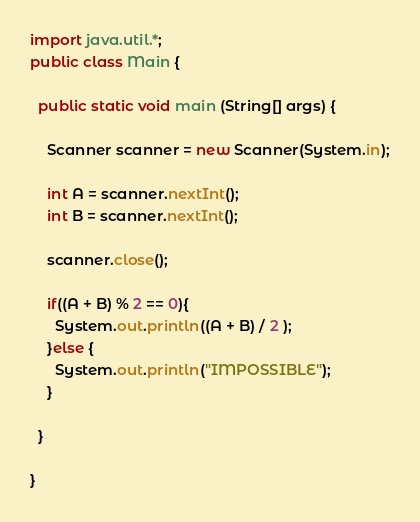<code> <loc_0><loc_0><loc_500><loc_500><_Java_>import java.util.*;
public class Main {

  public static void main (String[] args) {
	
    Scanner scanner = new Scanner(System.in);
    
    int A = scanner.nextInt();
    int B = scanner.nextInt();

    scanner.close();

    if((A + B) % 2 == 0){
      System.out.println((A + B) / 2 );
    }else {
      System.out.println("IMPOSSIBLE");
    }
    
  }

}</code> 